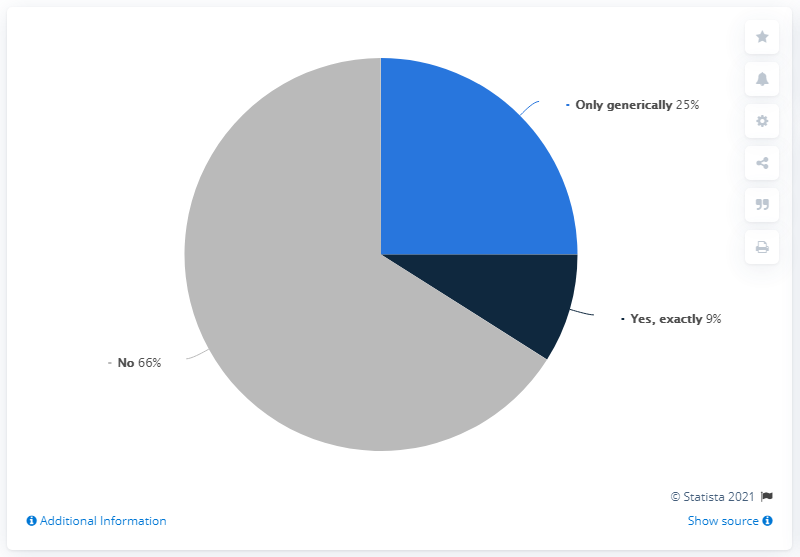Identify some key points in this picture. The colored segment that forms a right angle is blue. 